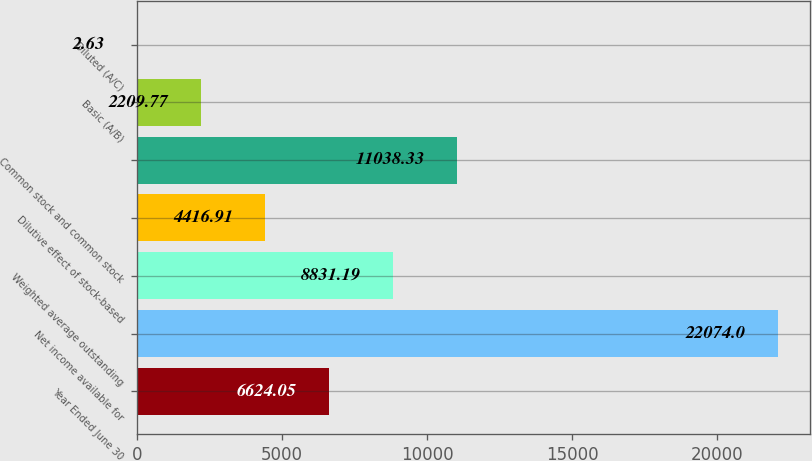Convert chart to OTSL. <chart><loc_0><loc_0><loc_500><loc_500><bar_chart><fcel>Year Ended June 30<fcel>Net income available for<fcel>Weighted average outstanding<fcel>Dilutive effect of stock-based<fcel>Common stock and common stock<fcel>Basic (A/B)<fcel>Diluted (A/C)<nl><fcel>6624.05<fcel>22074<fcel>8831.19<fcel>4416.91<fcel>11038.3<fcel>2209.77<fcel>2.63<nl></chart> 